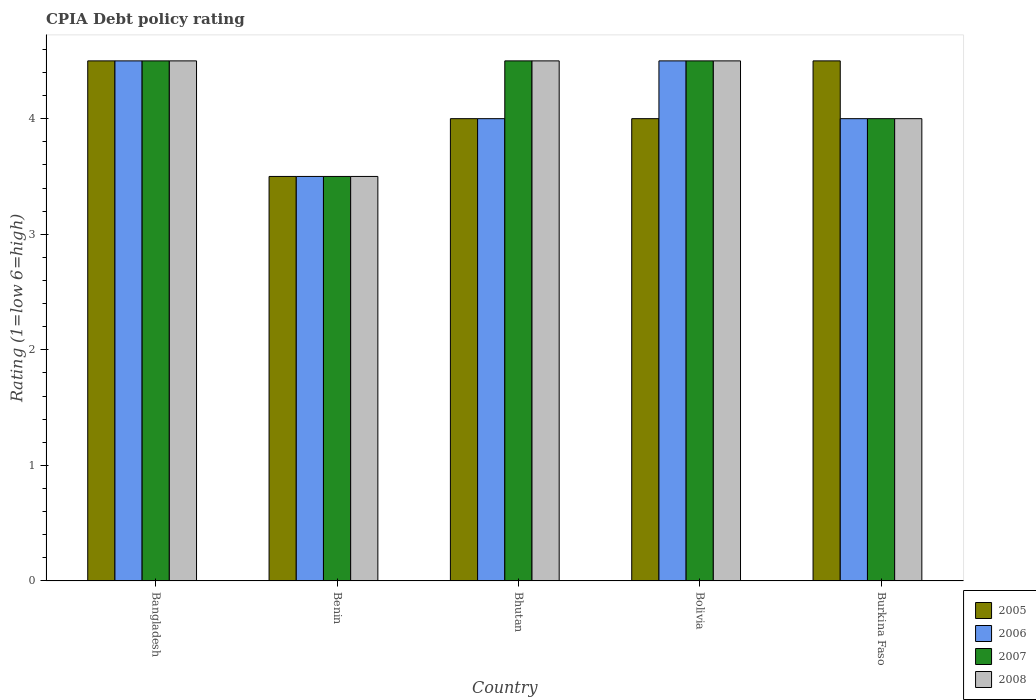How many bars are there on the 5th tick from the left?
Ensure brevity in your answer.  4. How many bars are there on the 3rd tick from the right?
Your answer should be compact. 4. What is the label of the 5th group of bars from the left?
Your answer should be compact. Burkina Faso. In how many cases, is the number of bars for a given country not equal to the number of legend labels?
Your response must be concise. 0. In which country was the CPIA rating in 2007 maximum?
Offer a terse response. Bangladesh. In which country was the CPIA rating in 2007 minimum?
Keep it short and to the point. Benin. What is the difference between the CPIA rating in 2008 in Benin and that in Bhutan?
Your answer should be very brief. -1. What is the difference between the CPIA rating in 2005 in Bhutan and the CPIA rating in 2008 in Benin?
Make the answer very short. 0.5. What is the average CPIA rating in 2008 per country?
Provide a succinct answer. 4.2. What is the difference between the CPIA rating of/in 2005 and CPIA rating of/in 2006 in Bhutan?
Give a very brief answer. 0. Is the difference between the CPIA rating in 2005 in Benin and Bhutan greater than the difference between the CPIA rating in 2006 in Benin and Bhutan?
Offer a very short reply. No. What is the difference between the highest and the lowest CPIA rating in 2008?
Ensure brevity in your answer.  1. Is it the case that in every country, the sum of the CPIA rating in 2006 and CPIA rating in 2005 is greater than the sum of CPIA rating in 2007 and CPIA rating in 2008?
Your answer should be very brief. No. What does the 4th bar from the right in Benin represents?
Your answer should be compact. 2005. How many bars are there?
Provide a short and direct response. 20. Are all the bars in the graph horizontal?
Offer a very short reply. No. Are the values on the major ticks of Y-axis written in scientific E-notation?
Offer a terse response. No. Does the graph contain any zero values?
Offer a very short reply. No. Does the graph contain grids?
Make the answer very short. No. Where does the legend appear in the graph?
Make the answer very short. Bottom right. How are the legend labels stacked?
Make the answer very short. Vertical. What is the title of the graph?
Offer a very short reply. CPIA Debt policy rating. Does "1965" appear as one of the legend labels in the graph?
Give a very brief answer. No. What is the Rating (1=low 6=high) in 2006 in Bangladesh?
Provide a succinct answer. 4.5. What is the Rating (1=low 6=high) in 2007 in Benin?
Give a very brief answer. 3.5. What is the Rating (1=low 6=high) in 2008 in Benin?
Make the answer very short. 3.5. What is the Rating (1=low 6=high) in 2007 in Bhutan?
Provide a succinct answer. 4.5. What is the Rating (1=low 6=high) in 2006 in Bolivia?
Provide a succinct answer. 4.5. Across all countries, what is the maximum Rating (1=low 6=high) in 2005?
Provide a short and direct response. 4.5. Across all countries, what is the maximum Rating (1=low 6=high) of 2006?
Keep it short and to the point. 4.5. Across all countries, what is the minimum Rating (1=low 6=high) in 2005?
Give a very brief answer. 3.5. Across all countries, what is the minimum Rating (1=low 6=high) of 2008?
Your answer should be compact. 3.5. What is the total Rating (1=low 6=high) in 2005 in the graph?
Your answer should be very brief. 20.5. What is the total Rating (1=low 6=high) of 2006 in the graph?
Ensure brevity in your answer.  20.5. What is the total Rating (1=low 6=high) of 2007 in the graph?
Ensure brevity in your answer.  21. What is the total Rating (1=low 6=high) in 2008 in the graph?
Provide a succinct answer. 21. What is the difference between the Rating (1=low 6=high) in 2006 in Bangladesh and that in Benin?
Ensure brevity in your answer.  1. What is the difference between the Rating (1=low 6=high) in 2005 in Bangladesh and that in Bhutan?
Provide a succinct answer. 0.5. What is the difference between the Rating (1=low 6=high) of 2008 in Bangladesh and that in Bhutan?
Your answer should be very brief. 0. What is the difference between the Rating (1=low 6=high) of 2005 in Bangladesh and that in Bolivia?
Provide a short and direct response. 0.5. What is the difference between the Rating (1=low 6=high) of 2007 in Bangladesh and that in Bolivia?
Your answer should be very brief. 0. What is the difference between the Rating (1=low 6=high) of 2005 in Bangladesh and that in Burkina Faso?
Offer a very short reply. 0. What is the difference between the Rating (1=low 6=high) of 2006 in Bangladesh and that in Burkina Faso?
Give a very brief answer. 0.5. What is the difference between the Rating (1=low 6=high) of 2007 in Bangladesh and that in Burkina Faso?
Offer a very short reply. 0.5. What is the difference between the Rating (1=low 6=high) in 2008 in Bangladesh and that in Burkina Faso?
Your answer should be very brief. 0.5. What is the difference between the Rating (1=low 6=high) in 2005 in Benin and that in Bhutan?
Make the answer very short. -0.5. What is the difference between the Rating (1=low 6=high) in 2006 in Benin and that in Bhutan?
Your response must be concise. -0.5. What is the difference between the Rating (1=low 6=high) in 2005 in Benin and that in Bolivia?
Your answer should be compact. -0.5. What is the difference between the Rating (1=low 6=high) in 2005 in Benin and that in Burkina Faso?
Keep it short and to the point. -1. What is the difference between the Rating (1=low 6=high) of 2005 in Bhutan and that in Burkina Faso?
Ensure brevity in your answer.  -0.5. What is the difference between the Rating (1=low 6=high) in 2006 in Bhutan and that in Burkina Faso?
Provide a succinct answer. 0. What is the difference between the Rating (1=low 6=high) in 2007 in Bhutan and that in Burkina Faso?
Your answer should be compact. 0.5. What is the difference between the Rating (1=low 6=high) of 2008 in Bhutan and that in Burkina Faso?
Make the answer very short. 0.5. What is the difference between the Rating (1=low 6=high) in 2005 in Bangladesh and the Rating (1=low 6=high) in 2006 in Benin?
Your answer should be very brief. 1. What is the difference between the Rating (1=low 6=high) in 2005 in Bangladesh and the Rating (1=low 6=high) in 2008 in Benin?
Make the answer very short. 1. What is the difference between the Rating (1=low 6=high) in 2006 in Bangladesh and the Rating (1=low 6=high) in 2008 in Benin?
Provide a succinct answer. 1. What is the difference between the Rating (1=low 6=high) of 2005 in Bangladesh and the Rating (1=low 6=high) of 2007 in Bhutan?
Your answer should be compact. 0. What is the difference between the Rating (1=low 6=high) of 2005 in Bangladesh and the Rating (1=low 6=high) of 2008 in Bhutan?
Provide a short and direct response. 0. What is the difference between the Rating (1=low 6=high) of 2006 in Bangladesh and the Rating (1=low 6=high) of 2007 in Bhutan?
Offer a very short reply. 0. What is the difference between the Rating (1=low 6=high) of 2006 in Bangladesh and the Rating (1=low 6=high) of 2008 in Bhutan?
Ensure brevity in your answer.  0. What is the difference between the Rating (1=low 6=high) of 2005 in Bangladesh and the Rating (1=low 6=high) of 2007 in Bolivia?
Give a very brief answer. 0. What is the difference between the Rating (1=low 6=high) of 2005 in Bangladesh and the Rating (1=low 6=high) of 2008 in Bolivia?
Your response must be concise. 0. What is the difference between the Rating (1=low 6=high) in 2006 in Bangladesh and the Rating (1=low 6=high) in 2007 in Bolivia?
Make the answer very short. 0. What is the difference between the Rating (1=low 6=high) in 2005 in Bangladesh and the Rating (1=low 6=high) in 2006 in Burkina Faso?
Keep it short and to the point. 0.5. What is the difference between the Rating (1=low 6=high) of 2005 in Bangladesh and the Rating (1=low 6=high) of 2007 in Burkina Faso?
Ensure brevity in your answer.  0.5. What is the difference between the Rating (1=low 6=high) in 2005 in Bangladesh and the Rating (1=low 6=high) in 2008 in Burkina Faso?
Offer a very short reply. 0.5. What is the difference between the Rating (1=low 6=high) of 2006 in Bangladesh and the Rating (1=low 6=high) of 2007 in Burkina Faso?
Your answer should be very brief. 0.5. What is the difference between the Rating (1=low 6=high) of 2006 in Benin and the Rating (1=low 6=high) of 2008 in Bhutan?
Offer a very short reply. -1. What is the difference between the Rating (1=low 6=high) in 2005 in Benin and the Rating (1=low 6=high) in 2007 in Bolivia?
Give a very brief answer. -1. What is the difference between the Rating (1=low 6=high) in 2006 in Benin and the Rating (1=low 6=high) in 2007 in Bolivia?
Give a very brief answer. -1. What is the difference between the Rating (1=low 6=high) of 2005 in Benin and the Rating (1=low 6=high) of 2006 in Burkina Faso?
Make the answer very short. -0.5. What is the difference between the Rating (1=low 6=high) in 2006 in Benin and the Rating (1=low 6=high) in 2007 in Burkina Faso?
Give a very brief answer. -0.5. What is the difference between the Rating (1=low 6=high) of 2005 in Bhutan and the Rating (1=low 6=high) of 2008 in Bolivia?
Provide a succinct answer. -0.5. What is the difference between the Rating (1=low 6=high) of 2006 in Bhutan and the Rating (1=low 6=high) of 2007 in Bolivia?
Offer a terse response. -0.5. What is the difference between the Rating (1=low 6=high) of 2006 in Bhutan and the Rating (1=low 6=high) of 2008 in Bolivia?
Provide a succinct answer. -0.5. What is the difference between the Rating (1=low 6=high) of 2005 in Bhutan and the Rating (1=low 6=high) of 2006 in Burkina Faso?
Your response must be concise. 0. What is the difference between the Rating (1=low 6=high) of 2006 in Bhutan and the Rating (1=low 6=high) of 2007 in Burkina Faso?
Provide a short and direct response. 0. What is the difference between the Rating (1=low 6=high) of 2006 in Bhutan and the Rating (1=low 6=high) of 2008 in Burkina Faso?
Make the answer very short. 0. What is the difference between the Rating (1=low 6=high) in 2005 in Bolivia and the Rating (1=low 6=high) in 2008 in Burkina Faso?
Offer a very short reply. 0. What is the difference between the Rating (1=low 6=high) in 2007 in Bolivia and the Rating (1=low 6=high) in 2008 in Burkina Faso?
Your answer should be very brief. 0.5. What is the average Rating (1=low 6=high) of 2005 per country?
Provide a succinct answer. 4.1. What is the average Rating (1=low 6=high) in 2007 per country?
Offer a terse response. 4.2. What is the difference between the Rating (1=low 6=high) of 2005 and Rating (1=low 6=high) of 2006 in Bangladesh?
Ensure brevity in your answer.  0. What is the difference between the Rating (1=low 6=high) of 2005 and Rating (1=low 6=high) of 2007 in Bangladesh?
Your answer should be compact. 0. What is the difference between the Rating (1=low 6=high) of 2005 and Rating (1=low 6=high) of 2008 in Bangladesh?
Your answer should be compact. 0. What is the difference between the Rating (1=low 6=high) in 2006 and Rating (1=low 6=high) in 2007 in Bangladesh?
Give a very brief answer. 0. What is the difference between the Rating (1=low 6=high) in 2006 and Rating (1=low 6=high) in 2008 in Bangladesh?
Provide a succinct answer. 0. What is the difference between the Rating (1=low 6=high) of 2005 and Rating (1=low 6=high) of 2008 in Benin?
Keep it short and to the point. 0. What is the difference between the Rating (1=low 6=high) in 2006 and Rating (1=low 6=high) in 2008 in Benin?
Make the answer very short. 0. What is the difference between the Rating (1=low 6=high) of 2005 and Rating (1=low 6=high) of 2006 in Bhutan?
Offer a terse response. 0. What is the difference between the Rating (1=low 6=high) of 2005 and Rating (1=low 6=high) of 2007 in Bhutan?
Keep it short and to the point. -0.5. What is the difference between the Rating (1=low 6=high) in 2005 and Rating (1=low 6=high) in 2008 in Bhutan?
Offer a terse response. -0.5. What is the difference between the Rating (1=low 6=high) of 2007 and Rating (1=low 6=high) of 2008 in Bhutan?
Your response must be concise. 0. What is the difference between the Rating (1=low 6=high) of 2005 and Rating (1=low 6=high) of 2006 in Bolivia?
Your answer should be very brief. -0.5. What is the difference between the Rating (1=low 6=high) of 2006 and Rating (1=low 6=high) of 2007 in Bolivia?
Ensure brevity in your answer.  0. What is the difference between the Rating (1=low 6=high) in 2006 and Rating (1=low 6=high) in 2008 in Bolivia?
Your response must be concise. 0. What is the difference between the Rating (1=low 6=high) of 2005 and Rating (1=low 6=high) of 2006 in Burkina Faso?
Offer a terse response. 0.5. What is the difference between the Rating (1=low 6=high) of 2005 and Rating (1=low 6=high) of 2007 in Burkina Faso?
Give a very brief answer. 0.5. What is the difference between the Rating (1=low 6=high) of 2006 and Rating (1=low 6=high) of 2007 in Burkina Faso?
Provide a succinct answer. 0. What is the ratio of the Rating (1=low 6=high) in 2007 in Bangladesh to that in Benin?
Offer a terse response. 1.29. What is the ratio of the Rating (1=low 6=high) in 2008 in Bangladesh to that in Benin?
Your response must be concise. 1.29. What is the ratio of the Rating (1=low 6=high) of 2005 in Bangladesh to that in Burkina Faso?
Provide a succinct answer. 1. What is the ratio of the Rating (1=low 6=high) of 2008 in Bangladesh to that in Burkina Faso?
Keep it short and to the point. 1.12. What is the ratio of the Rating (1=low 6=high) of 2005 in Benin to that in Bhutan?
Your response must be concise. 0.88. What is the ratio of the Rating (1=low 6=high) of 2006 in Benin to that in Bhutan?
Offer a very short reply. 0.88. What is the ratio of the Rating (1=low 6=high) in 2007 in Benin to that in Bhutan?
Ensure brevity in your answer.  0.78. What is the ratio of the Rating (1=low 6=high) of 2008 in Benin to that in Bolivia?
Ensure brevity in your answer.  0.78. What is the ratio of the Rating (1=low 6=high) of 2006 in Benin to that in Burkina Faso?
Provide a short and direct response. 0.88. What is the ratio of the Rating (1=low 6=high) of 2007 in Benin to that in Burkina Faso?
Provide a succinct answer. 0.88. What is the ratio of the Rating (1=low 6=high) in 2008 in Benin to that in Burkina Faso?
Your answer should be compact. 0.88. What is the ratio of the Rating (1=low 6=high) in 2005 in Bhutan to that in Bolivia?
Give a very brief answer. 1. What is the ratio of the Rating (1=low 6=high) of 2006 in Bhutan to that in Bolivia?
Ensure brevity in your answer.  0.89. What is the ratio of the Rating (1=low 6=high) of 2005 in Bhutan to that in Burkina Faso?
Offer a terse response. 0.89. What is the ratio of the Rating (1=low 6=high) in 2007 in Bhutan to that in Burkina Faso?
Keep it short and to the point. 1.12. What is the ratio of the Rating (1=low 6=high) of 2005 in Bolivia to that in Burkina Faso?
Your answer should be compact. 0.89. What is the ratio of the Rating (1=low 6=high) of 2007 in Bolivia to that in Burkina Faso?
Make the answer very short. 1.12. What is the ratio of the Rating (1=low 6=high) of 2008 in Bolivia to that in Burkina Faso?
Ensure brevity in your answer.  1.12. What is the difference between the highest and the lowest Rating (1=low 6=high) in 2007?
Your answer should be very brief. 1. 